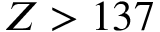<formula> <loc_0><loc_0><loc_500><loc_500>Z > 1 3 7</formula> 